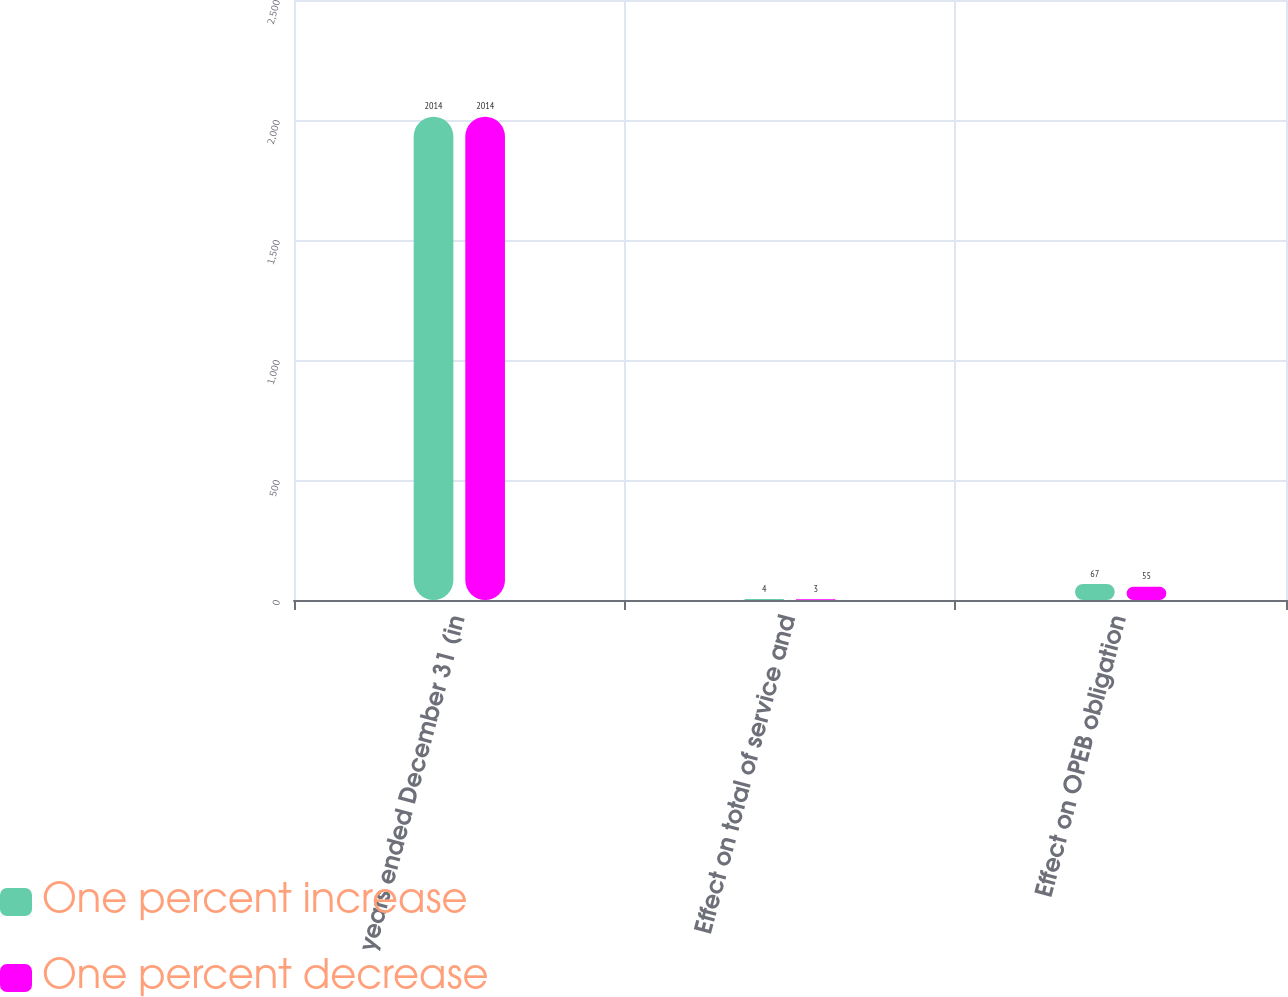Convert chart to OTSL. <chart><loc_0><loc_0><loc_500><loc_500><stacked_bar_chart><ecel><fcel>years ended December 31 (in<fcel>Effect on total of service and<fcel>Effect on OPEB obligation<nl><fcel>One percent increase<fcel>2014<fcel>4<fcel>67<nl><fcel>One percent decrease<fcel>2014<fcel>3<fcel>55<nl></chart> 